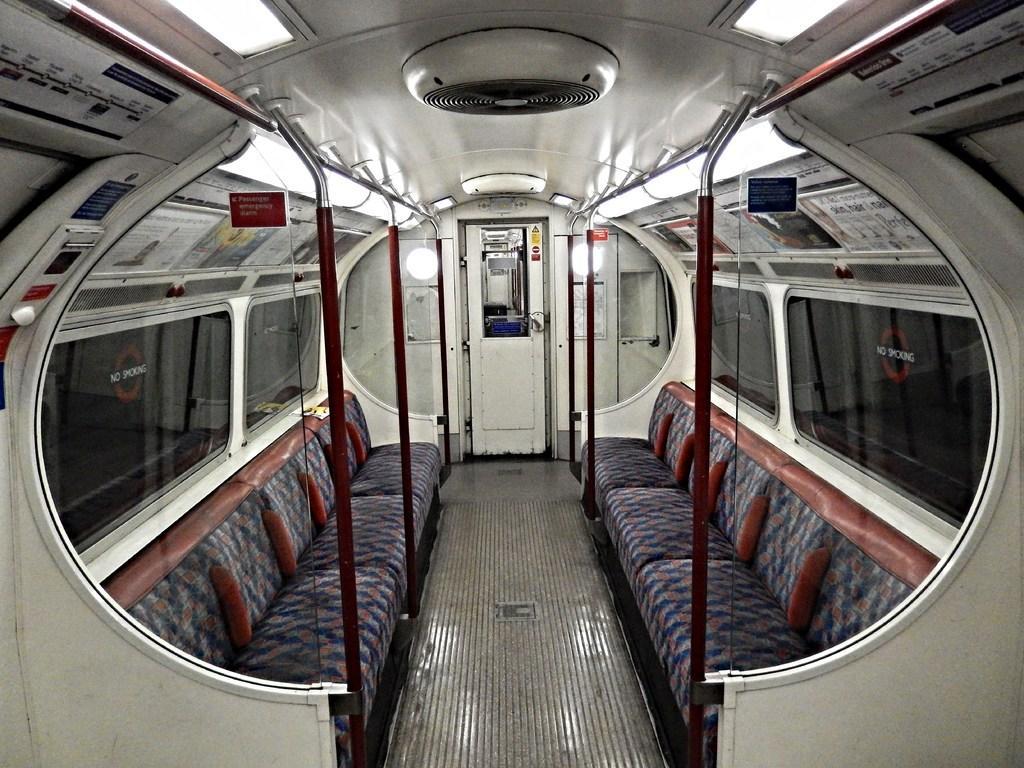Please provide a concise description of this image. Picture inside of a vehicle. These are lights, poles, door and glass windows. Here we can see couches. 